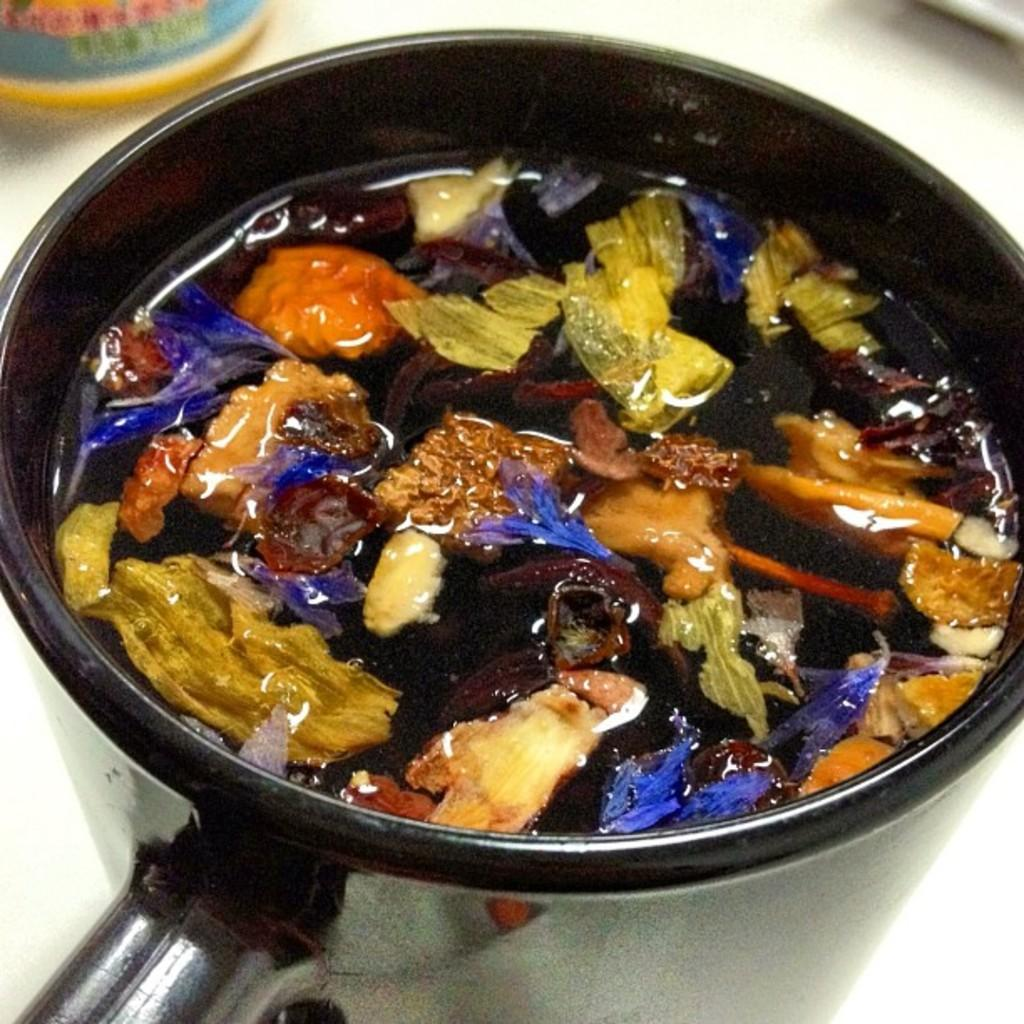What is the main subject of the image? The main subject of the image is objects in a liquid in a pan. What can be inferred about the objects in the pan? The objects are submerged in a liquid, which suggests they might be cooking or being prepared in some way. What is the color of the background in the image? The background is white in color. What else can be seen in the image besides the objects in the pan? There are other objects in the background of the image. How does the mint affect the current flow in the image? There is no mint or current flow present in the image; it features objects in a liquid in a pan with a white background. 